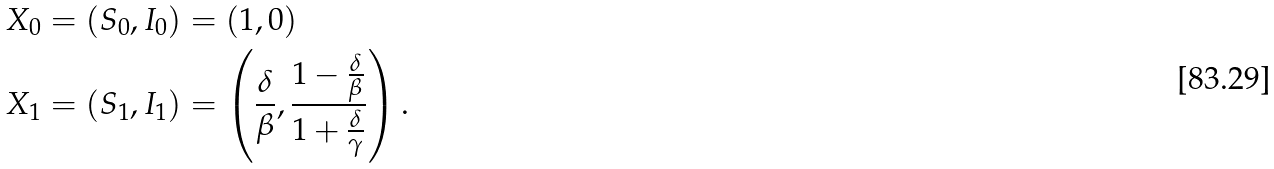Convert formula to latex. <formula><loc_0><loc_0><loc_500><loc_500>X _ { 0 } & = ( S _ { 0 } , I _ { 0 } ) = ( 1 , 0 ) \\ X _ { 1 } & = ( S _ { 1 } , I _ { 1 } ) = \left ( \frac { \delta } { \beta } , \frac { 1 - \frac { \delta } { \beta } } { 1 + \frac { \delta } { \gamma } } \right ) .</formula> 